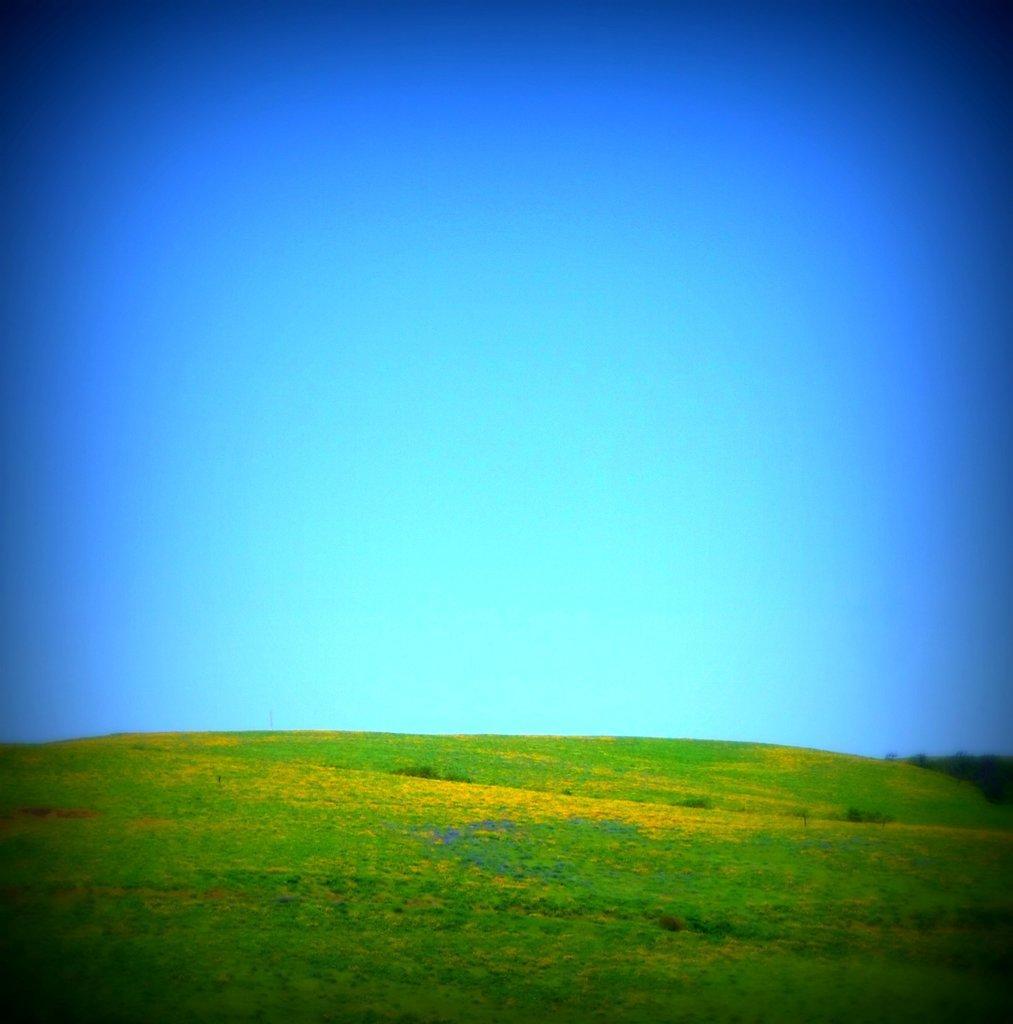Can you describe this image briefly? In this image downside it is grass, at the top it's a beautiful blue color sky. 